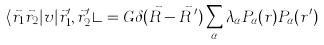<formula> <loc_0><loc_0><loc_500><loc_500>\langle \vec { r } _ { 1 } \vec { r } _ { 2 } | v | \vec { r } _ { 1 } ^ { \prime } , \vec { r } _ { 2 } ^ { \prime } \rangle = G \delta ( \vec { R } - \vec { R } \, ^ { \prime } ) \sum _ { \alpha } \lambda _ { \alpha } P _ { \alpha } ( r ) P _ { \alpha } ( r ^ { \prime } )</formula> 